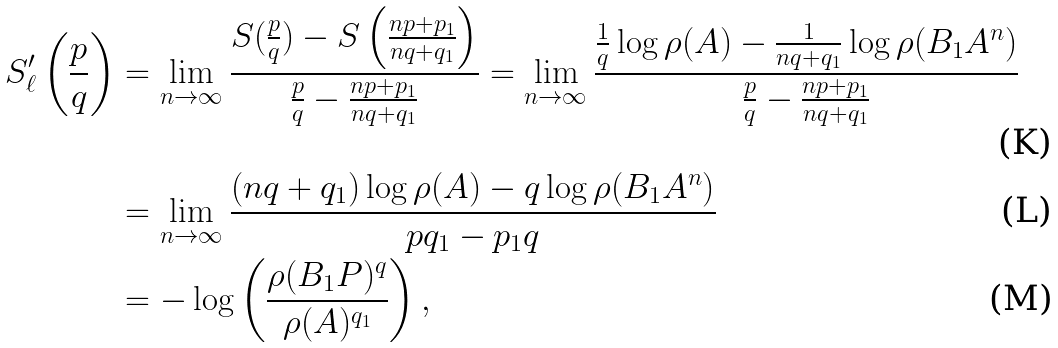<formula> <loc_0><loc_0><loc_500><loc_500>S _ { \ell } ^ { \prime } \left ( \frac { p } { q } \right ) & = \lim _ { n \to \infty } \frac { S ( \frac { p } { q } ) - S \left ( \frac { n p + p _ { 1 } } { n q + q _ { 1 } } \right ) } { \frac { p } { q } - \frac { n p + p _ { 1 } } { n q + q _ { 1 } } } = \lim _ { n \to \infty } \frac { \frac { 1 } { q } \log \rho ( A ) - \frac { 1 } { n q + q _ { 1 } } \log \rho ( B _ { 1 } A ^ { n } ) } { \frac { p } { q } - \frac { n p + p _ { 1 } } { n q + q _ { 1 } } } \\ & = \lim _ { n \to \infty } \frac { ( n q + q _ { 1 } ) \log \rho ( A ) - q \log \rho ( B _ { 1 } A ^ { n } ) } { p q _ { 1 } - p _ { 1 } q } \\ & = - \log \left ( \frac { \rho ( B _ { 1 } P ) ^ { q } } { \rho ( A ) ^ { q _ { 1 } } } \right ) ,</formula> 